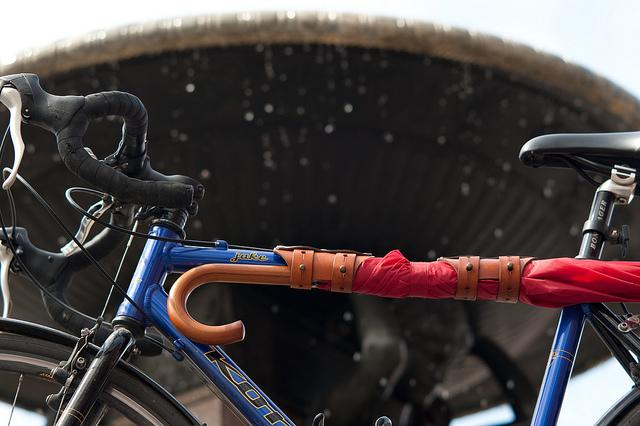The cyclist is most prepared for which weather today?

Choices:
A) tornado
B) rain
C) earthquake
D) tsunami rain 